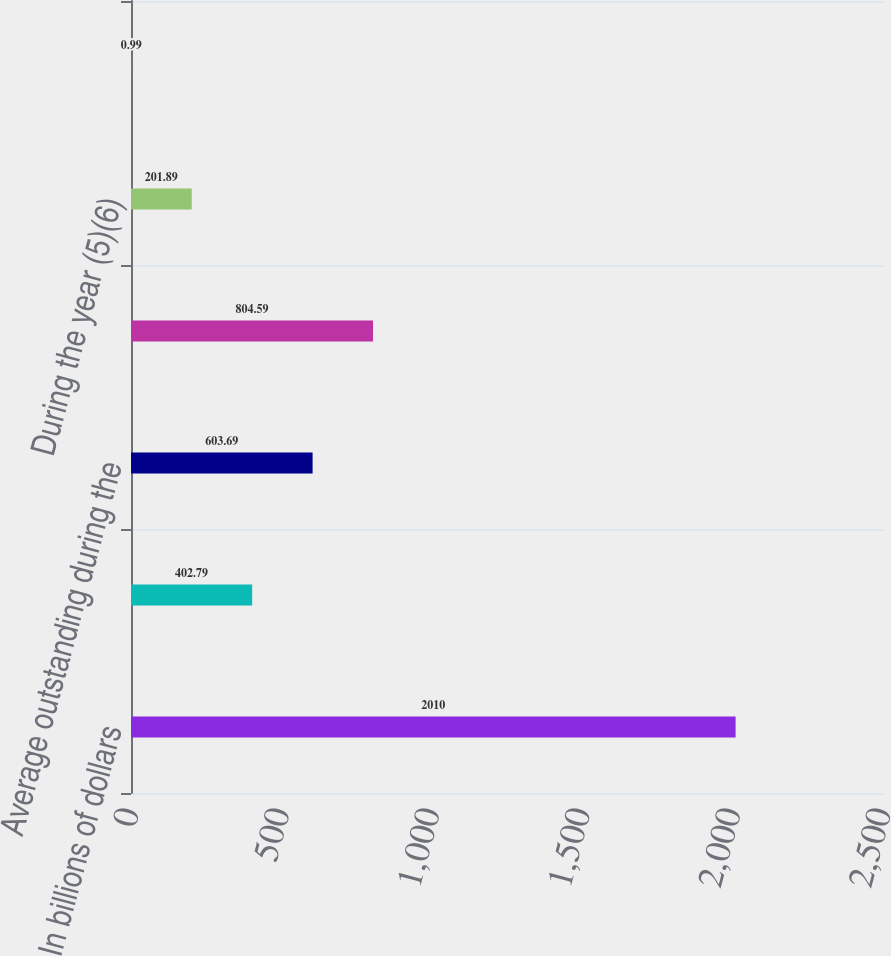Convert chart. <chart><loc_0><loc_0><loc_500><loc_500><bar_chart><fcel>In billions of dollars<fcel>Amounts outstanding at year<fcel>Average outstanding during the<fcel>Maximum month-end outstanding<fcel>During the year (5)(6)<fcel>At year end (7)<nl><fcel>2010<fcel>402.79<fcel>603.69<fcel>804.59<fcel>201.89<fcel>0.99<nl></chart> 